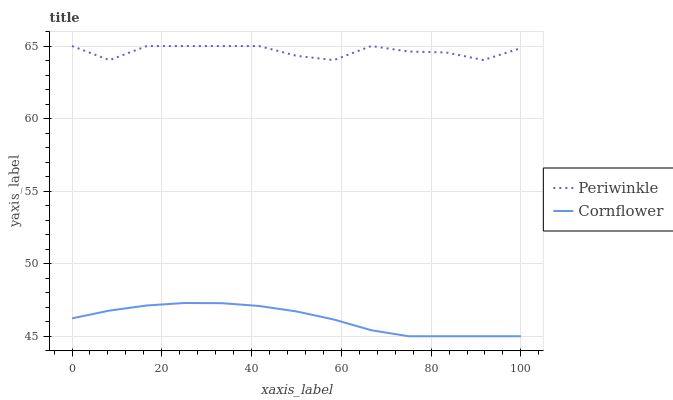Does Periwinkle have the minimum area under the curve?
Answer yes or no. No. Is Periwinkle the smoothest?
Answer yes or no. No. Does Periwinkle have the lowest value?
Answer yes or no. No. Is Cornflower less than Periwinkle?
Answer yes or no. Yes. Is Periwinkle greater than Cornflower?
Answer yes or no. Yes. Does Cornflower intersect Periwinkle?
Answer yes or no. No. 